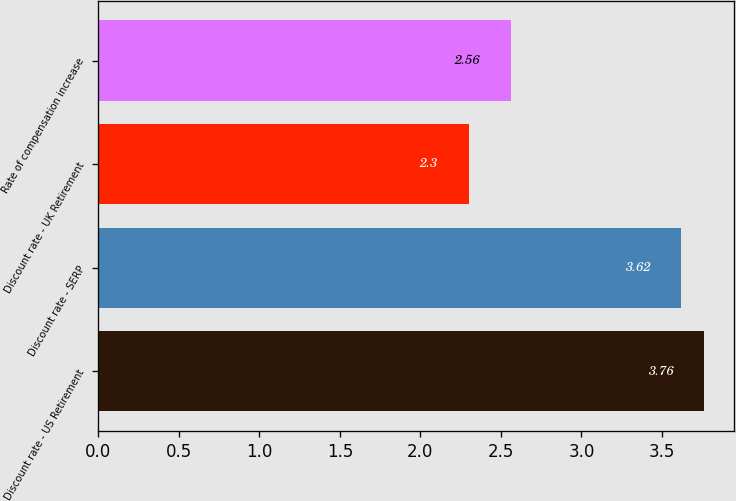Convert chart to OTSL. <chart><loc_0><loc_0><loc_500><loc_500><bar_chart><fcel>Discount rate - US Retirement<fcel>Discount rate - SERP<fcel>Discount rate - UK Retirement<fcel>Rate of compensation increase<nl><fcel>3.76<fcel>3.62<fcel>2.3<fcel>2.56<nl></chart> 